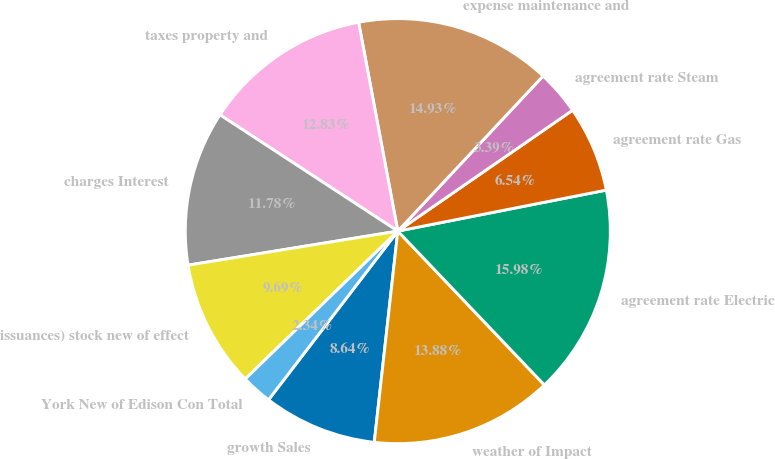Convert chart to OTSL. <chart><loc_0><loc_0><loc_500><loc_500><pie_chart><fcel>growth Sales<fcel>weather of Impact<fcel>agreement rate Electric<fcel>agreement rate Gas<fcel>agreement rate Steam<fcel>expense maintenance and<fcel>taxes property and<fcel>charges Interest<fcel>issuances) stock new of effect<fcel>York New of Edison Con Total<nl><fcel>8.64%<fcel>13.88%<fcel>15.98%<fcel>6.54%<fcel>3.39%<fcel>14.93%<fcel>12.83%<fcel>11.78%<fcel>9.69%<fcel>2.34%<nl></chart> 